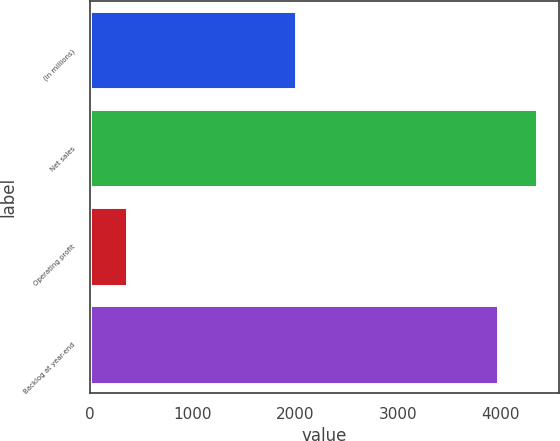<chart> <loc_0><loc_0><loc_500><loc_500><bar_chart><fcel>(In millions)<fcel>Net sales<fcel>Operating profit<fcel>Backlog at year-end<nl><fcel>2005<fcel>4350.6<fcel>365<fcel>3974<nl></chart> 